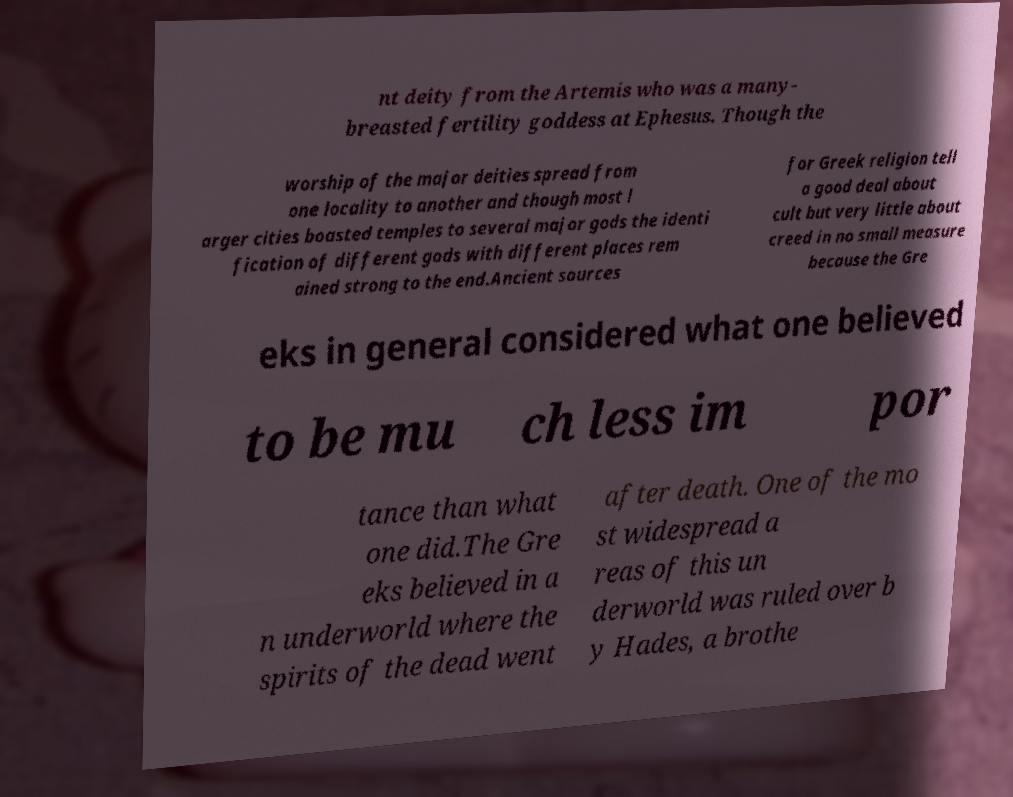Can you read and provide the text displayed in the image?This photo seems to have some interesting text. Can you extract and type it out for me? nt deity from the Artemis who was a many- breasted fertility goddess at Ephesus. Though the worship of the major deities spread from one locality to another and though most l arger cities boasted temples to several major gods the identi fication of different gods with different places rem ained strong to the end.Ancient sources for Greek religion tell a good deal about cult but very little about creed in no small measure because the Gre eks in general considered what one believed to be mu ch less im por tance than what one did.The Gre eks believed in a n underworld where the spirits of the dead went after death. One of the mo st widespread a reas of this un derworld was ruled over b y Hades, a brothe 